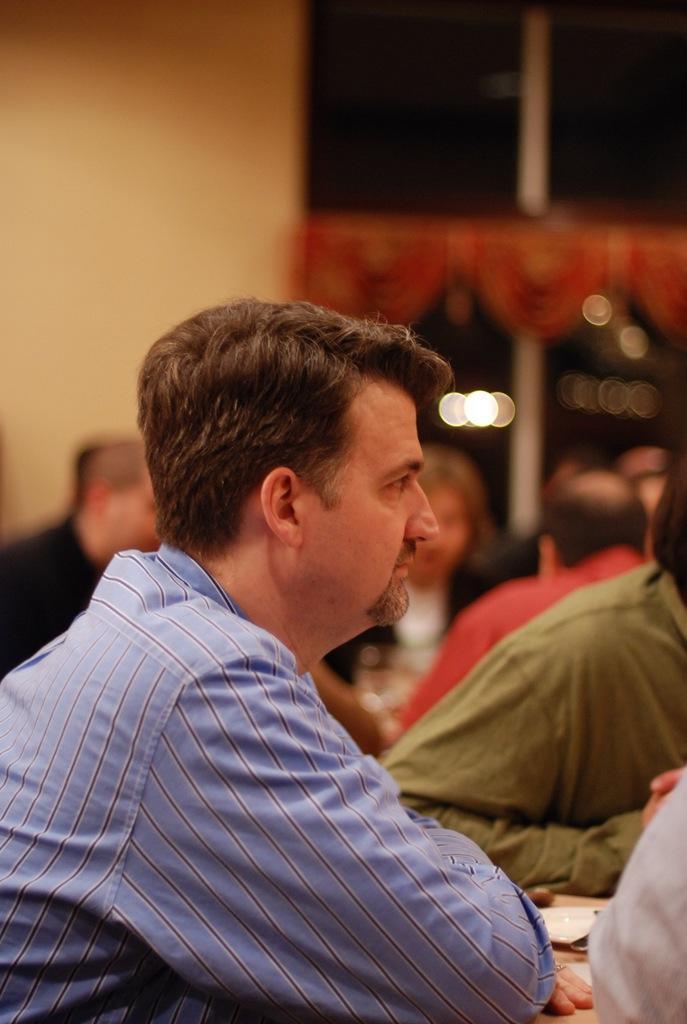Could you give a brief overview of what you see in this image? In this picture I can observe a man sitting in the chair in front of a table. There are some people in the background sitting in their chairs. The man is wearing violet color shirt. In the background I can observe a wall. 